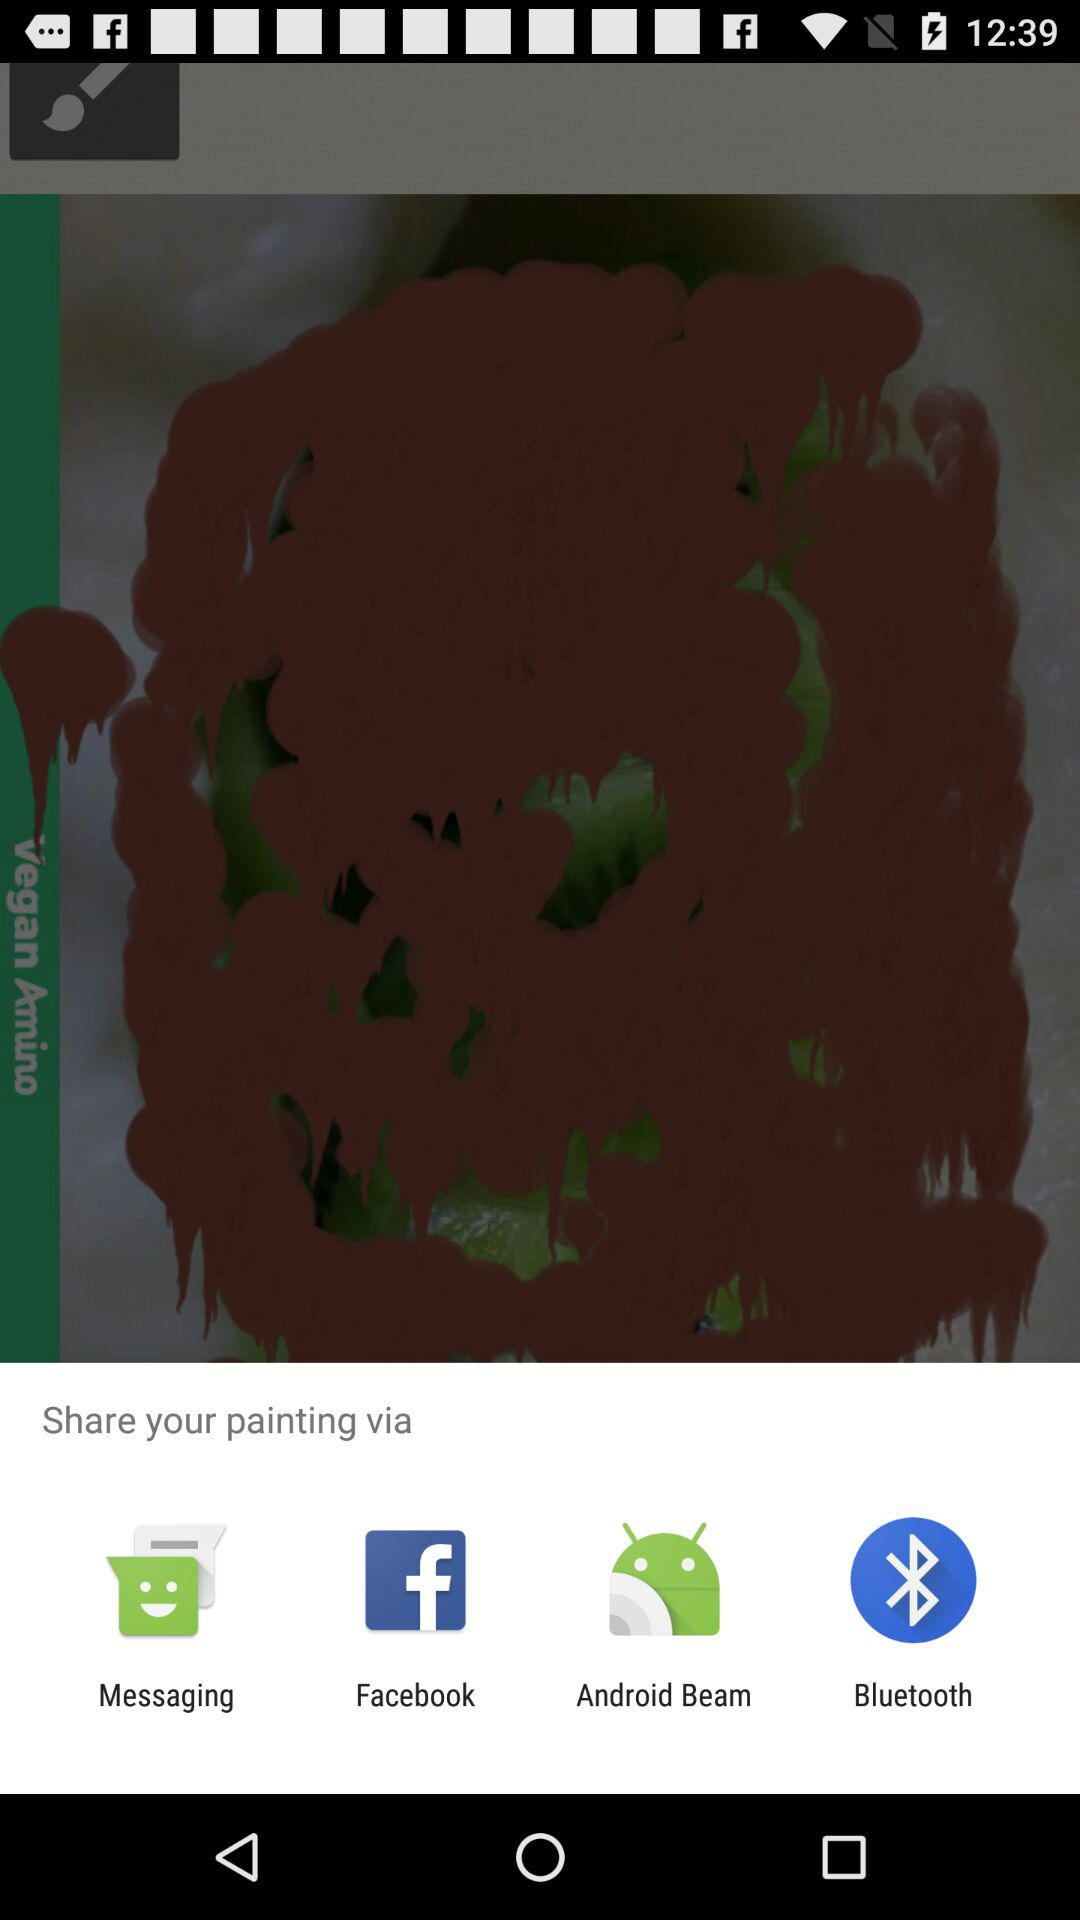Who created the painting?
When the provided information is insufficient, respond with <no answer>. <no answer> 